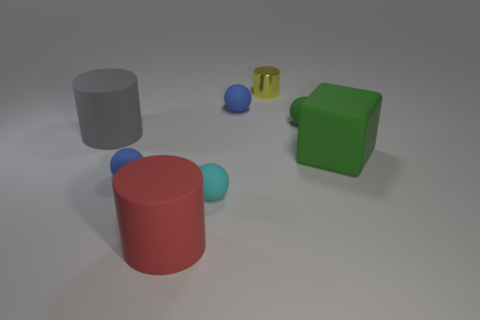Is there any other thing that has the same material as the small yellow thing?
Provide a succinct answer. No. Is there a small ball of the same color as the small cylinder?
Your answer should be very brief. No. Is the small blue thing that is behind the small green object made of the same material as the small blue ball in front of the small green ball?
Ensure brevity in your answer.  Yes. What color is the big cube?
Give a very brief answer. Green. What is the size of the blue object in front of the large object that is to the right of the tiny metal cylinder that is to the left of the cube?
Your answer should be very brief. Small. How many other things are there of the same size as the yellow metallic thing?
Keep it short and to the point. 4. How many big green objects are made of the same material as the yellow cylinder?
Make the answer very short. 0. There is a big rubber object on the right side of the tiny yellow shiny cylinder; what shape is it?
Keep it short and to the point. Cube. Is the material of the green cube the same as the small blue thing behind the rubber cube?
Offer a terse response. Yes. Is there a big cyan shiny object?
Your response must be concise. No. 